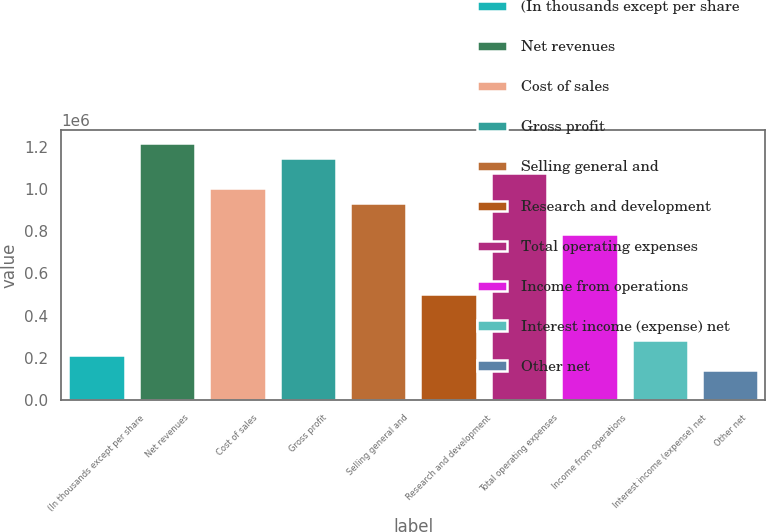<chart> <loc_0><loc_0><loc_500><loc_500><bar_chart><fcel>(In thousands except per share<fcel>Net revenues<fcel>Cost of sales<fcel>Gross profit<fcel>Selling general and<fcel>Research and development<fcel>Total operating expenses<fcel>Income from operations<fcel>Interest income (expense) net<fcel>Other net<nl><fcel>214900<fcel>1.21776e+06<fcel>1.00286e+06<fcel>1.14613e+06<fcel>931231<fcel>501433<fcel>1.0745e+06<fcel>787965<fcel>286533<fcel>143267<nl></chart> 